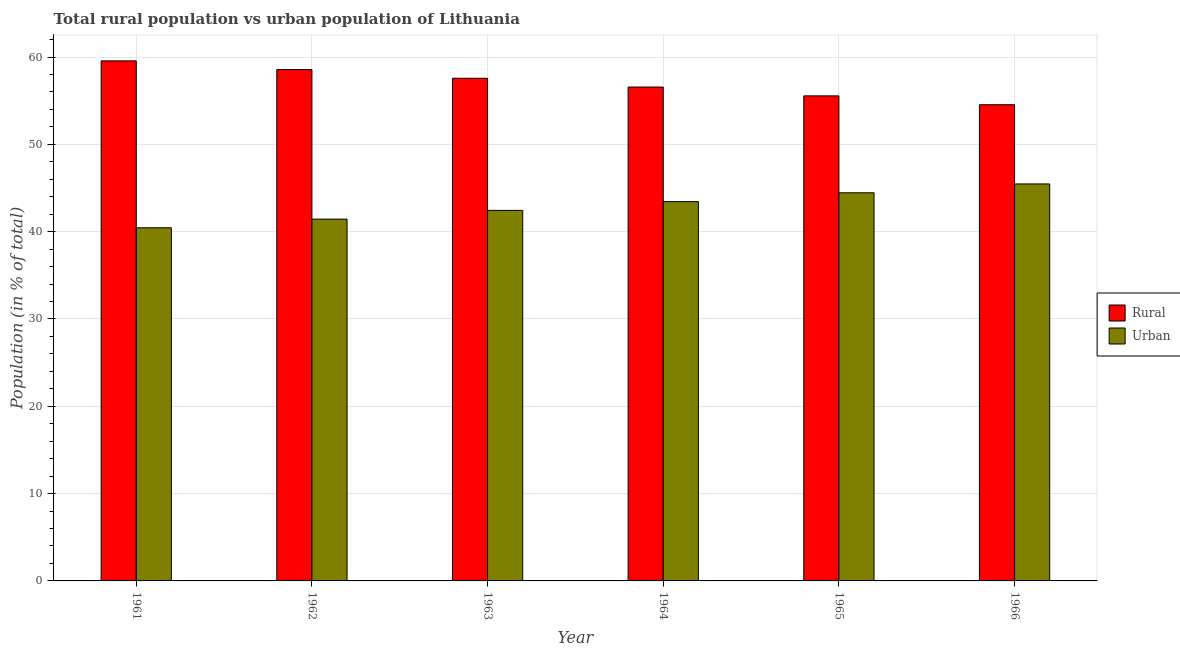How many different coloured bars are there?
Keep it short and to the point. 2. Are the number of bars per tick equal to the number of legend labels?
Your answer should be compact. Yes. What is the rural population in 1961?
Your response must be concise. 59.56. Across all years, what is the maximum rural population?
Your response must be concise. 59.56. Across all years, what is the minimum urban population?
Your answer should be compact. 40.44. In which year was the urban population maximum?
Ensure brevity in your answer.  1966. What is the total urban population in the graph?
Your answer should be very brief. 257.67. What is the difference between the rural population in 1962 and that in 1965?
Make the answer very short. 3.02. What is the difference between the rural population in 1965 and the urban population in 1966?
Make the answer very short. 1.02. What is the average urban population per year?
Ensure brevity in your answer.  42.94. In the year 1962, what is the difference between the urban population and rural population?
Offer a terse response. 0. What is the ratio of the urban population in 1962 to that in 1965?
Offer a terse response. 0.93. Is the rural population in 1964 less than that in 1966?
Your answer should be compact. No. Is the difference between the urban population in 1962 and 1965 greater than the difference between the rural population in 1962 and 1965?
Offer a very short reply. No. What is the difference between the highest and the second highest rural population?
Make the answer very short. 0.99. What is the difference between the highest and the lowest urban population?
Keep it short and to the point. 5.02. Is the sum of the rural population in 1965 and 1966 greater than the maximum urban population across all years?
Your response must be concise. Yes. What does the 1st bar from the left in 1965 represents?
Provide a short and direct response. Rural. What does the 1st bar from the right in 1966 represents?
Offer a terse response. Urban. Are all the bars in the graph horizontal?
Keep it short and to the point. No. How many years are there in the graph?
Ensure brevity in your answer.  6. What is the difference between two consecutive major ticks on the Y-axis?
Keep it short and to the point. 10. Are the values on the major ticks of Y-axis written in scientific E-notation?
Offer a terse response. No. Does the graph contain any zero values?
Keep it short and to the point. No. Does the graph contain grids?
Keep it short and to the point. Yes. How are the legend labels stacked?
Provide a short and direct response. Vertical. What is the title of the graph?
Your response must be concise. Total rural population vs urban population of Lithuania. Does "Infant" appear as one of the legend labels in the graph?
Give a very brief answer. No. What is the label or title of the X-axis?
Ensure brevity in your answer.  Year. What is the label or title of the Y-axis?
Give a very brief answer. Population (in % of total). What is the Population (in % of total) in Rural in 1961?
Offer a terse response. 59.56. What is the Population (in % of total) in Urban in 1961?
Offer a terse response. 40.44. What is the Population (in % of total) of Rural in 1962?
Give a very brief answer. 58.56. What is the Population (in % of total) of Urban in 1962?
Your answer should be very brief. 41.44. What is the Population (in % of total) in Rural in 1963?
Provide a short and direct response. 57.57. What is the Population (in % of total) of Urban in 1963?
Give a very brief answer. 42.43. What is the Population (in % of total) in Rural in 1964?
Provide a short and direct response. 56.56. What is the Population (in % of total) in Urban in 1964?
Keep it short and to the point. 43.44. What is the Population (in % of total) in Rural in 1965?
Your answer should be compact. 55.55. What is the Population (in % of total) of Urban in 1965?
Keep it short and to the point. 44.45. What is the Population (in % of total) in Rural in 1966?
Offer a very short reply. 54.53. What is the Population (in % of total) of Urban in 1966?
Provide a short and direct response. 45.47. Across all years, what is the maximum Population (in % of total) of Rural?
Make the answer very short. 59.56. Across all years, what is the maximum Population (in % of total) in Urban?
Offer a very short reply. 45.47. Across all years, what is the minimum Population (in % of total) in Rural?
Ensure brevity in your answer.  54.53. Across all years, what is the minimum Population (in % of total) of Urban?
Provide a short and direct response. 40.44. What is the total Population (in % of total) in Rural in the graph?
Provide a succinct answer. 342.33. What is the total Population (in % of total) of Urban in the graph?
Ensure brevity in your answer.  257.67. What is the difference between the Population (in % of total) in Urban in 1961 and that in 1962?
Your answer should be compact. -0.99. What is the difference between the Population (in % of total) of Rural in 1961 and that in 1963?
Provide a short and direct response. 1.99. What is the difference between the Population (in % of total) in Urban in 1961 and that in 1963?
Your answer should be compact. -1.99. What is the difference between the Population (in % of total) of Rural in 1961 and that in 1964?
Offer a very short reply. 3. What is the difference between the Population (in % of total) in Urban in 1961 and that in 1964?
Offer a very short reply. -3. What is the difference between the Population (in % of total) in Rural in 1961 and that in 1965?
Your answer should be very brief. 4.01. What is the difference between the Population (in % of total) of Urban in 1961 and that in 1965?
Offer a terse response. -4.01. What is the difference between the Population (in % of total) in Rural in 1961 and that in 1966?
Keep it short and to the point. 5.02. What is the difference between the Population (in % of total) of Urban in 1961 and that in 1966?
Offer a terse response. -5.02. What is the difference between the Population (in % of total) of Rural in 1962 and that in 1963?
Your answer should be very brief. 1. What is the difference between the Population (in % of total) in Urban in 1962 and that in 1963?
Keep it short and to the point. -1. What is the difference between the Population (in % of total) in Rural in 1962 and that in 1964?
Keep it short and to the point. 2.01. What is the difference between the Population (in % of total) of Urban in 1962 and that in 1964?
Your answer should be compact. -2.01. What is the difference between the Population (in % of total) of Rural in 1962 and that in 1965?
Your answer should be compact. 3.02. What is the difference between the Population (in % of total) in Urban in 1962 and that in 1965?
Your answer should be compact. -3.02. What is the difference between the Population (in % of total) of Rural in 1962 and that in 1966?
Your answer should be very brief. 4.03. What is the difference between the Population (in % of total) in Urban in 1962 and that in 1966?
Provide a succinct answer. -4.03. What is the difference between the Population (in % of total) in Rural in 1963 and that in 1964?
Your answer should be compact. 1.01. What is the difference between the Population (in % of total) of Urban in 1963 and that in 1964?
Ensure brevity in your answer.  -1.01. What is the difference between the Population (in % of total) of Rural in 1963 and that in 1965?
Offer a terse response. 2.02. What is the difference between the Population (in % of total) of Urban in 1963 and that in 1965?
Keep it short and to the point. -2.02. What is the difference between the Population (in % of total) in Rural in 1963 and that in 1966?
Ensure brevity in your answer.  3.03. What is the difference between the Population (in % of total) in Urban in 1963 and that in 1966?
Give a very brief answer. -3.03. What is the difference between the Population (in % of total) of Rural in 1964 and that in 1965?
Your answer should be compact. 1.01. What is the difference between the Population (in % of total) in Urban in 1964 and that in 1965?
Provide a succinct answer. -1.01. What is the difference between the Population (in % of total) of Rural in 1964 and that in 1966?
Provide a short and direct response. 2.02. What is the difference between the Population (in % of total) in Urban in 1964 and that in 1966?
Keep it short and to the point. -2.02. What is the difference between the Population (in % of total) in Urban in 1965 and that in 1966?
Provide a succinct answer. -1.01. What is the difference between the Population (in % of total) in Rural in 1961 and the Population (in % of total) in Urban in 1962?
Keep it short and to the point. 18.12. What is the difference between the Population (in % of total) of Rural in 1961 and the Population (in % of total) of Urban in 1963?
Your answer should be compact. 17.12. What is the difference between the Population (in % of total) in Rural in 1961 and the Population (in % of total) in Urban in 1964?
Offer a very short reply. 16.12. What is the difference between the Population (in % of total) in Rural in 1961 and the Population (in % of total) in Urban in 1965?
Your answer should be very brief. 15.11. What is the difference between the Population (in % of total) in Rural in 1961 and the Population (in % of total) in Urban in 1966?
Provide a succinct answer. 14.09. What is the difference between the Population (in % of total) of Rural in 1962 and the Population (in % of total) of Urban in 1963?
Your answer should be very brief. 16.13. What is the difference between the Population (in % of total) of Rural in 1962 and the Population (in % of total) of Urban in 1964?
Your answer should be compact. 15.12. What is the difference between the Population (in % of total) of Rural in 1962 and the Population (in % of total) of Urban in 1965?
Offer a very short reply. 14.12. What is the difference between the Population (in % of total) of Rural in 1963 and the Population (in % of total) of Urban in 1964?
Give a very brief answer. 14.12. What is the difference between the Population (in % of total) of Rural in 1963 and the Population (in % of total) of Urban in 1965?
Provide a short and direct response. 13.12. What is the difference between the Population (in % of total) of Rural in 1963 and the Population (in % of total) of Urban in 1966?
Make the answer very short. 12.1. What is the difference between the Population (in % of total) in Rural in 1964 and the Population (in % of total) in Urban in 1965?
Provide a succinct answer. 12.11. What is the difference between the Population (in % of total) of Rural in 1964 and the Population (in % of total) of Urban in 1966?
Keep it short and to the point. 11.09. What is the difference between the Population (in % of total) of Rural in 1965 and the Population (in % of total) of Urban in 1966?
Provide a short and direct response. 10.09. What is the average Population (in % of total) of Rural per year?
Provide a short and direct response. 57.06. What is the average Population (in % of total) of Urban per year?
Keep it short and to the point. 42.94. In the year 1961, what is the difference between the Population (in % of total) of Rural and Population (in % of total) of Urban?
Your response must be concise. 19.11. In the year 1962, what is the difference between the Population (in % of total) of Rural and Population (in % of total) of Urban?
Provide a short and direct response. 17.13. In the year 1963, what is the difference between the Population (in % of total) in Rural and Population (in % of total) in Urban?
Provide a short and direct response. 15.13. In the year 1964, what is the difference between the Population (in % of total) of Rural and Population (in % of total) of Urban?
Offer a terse response. 13.12. In the year 1966, what is the difference between the Population (in % of total) in Rural and Population (in % of total) in Urban?
Your response must be concise. 9.07. What is the ratio of the Population (in % of total) in Rural in 1961 to that in 1962?
Offer a terse response. 1.02. What is the ratio of the Population (in % of total) of Urban in 1961 to that in 1962?
Provide a succinct answer. 0.98. What is the ratio of the Population (in % of total) in Rural in 1961 to that in 1963?
Make the answer very short. 1.03. What is the ratio of the Population (in % of total) in Urban in 1961 to that in 1963?
Your answer should be very brief. 0.95. What is the ratio of the Population (in % of total) in Rural in 1961 to that in 1964?
Ensure brevity in your answer.  1.05. What is the ratio of the Population (in % of total) in Urban in 1961 to that in 1964?
Provide a short and direct response. 0.93. What is the ratio of the Population (in % of total) of Rural in 1961 to that in 1965?
Offer a terse response. 1.07. What is the ratio of the Population (in % of total) in Urban in 1961 to that in 1965?
Your answer should be very brief. 0.91. What is the ratio of the Population (in % of total) in Rural in 1961 to that in 1966?
Offer a very short reply. 1.09. What is the ratio of the Population (in % of total) in Urban in 1961 to that in 1966?
Offer a terse response. 0.89. What is the ratio of the Population (in % of total) of Rural in 1962 to that in 1963?
Your answer should be compact. 1.02. What is the ratio of the Population (in % of total) of Urban in 1962 to that in 1963?
Give a very brief answer. 0.98. What is the ratio of the Population (in % of total) in Rural in 1962 to that in 1964?
Provide a short and direct response. 1.04. What is the ratio of the Population (in % of total) in Urban in 1962 to that in 1964?
Offer a very short reply. 0.95. What is the ratio of the Population (in % of total) in Rural in 1962 to that in 1965?
Provide a short and direct response. 1.05. What is the ratio of the Population (in % of total) in Urban in 1962 to that in 1965?
Offer a very short reply. 0.93. What is the ratio of the Population (in % of total) in Rural in 1962 to that in 1966?
Ensure brevity in your answer.  1.07. What is the ratio of the Population (in % of total) in Urban in 1962 to that in 1966?
Offer a very short reply. 0.91. What is the ratio of the Population (in % of total) in Rural in 1963 to that in 1964?
Offer a very short reply. 1.02. What is the ratio of the Population (in % of total) in Urban in 1963 to that in 1964?
Give a very brief answer. 0.98. What is the ratio of the Population (in % of total) of Rural in 1963 to that in 1965?
Provide a short and direct response. 1.04. What is the ratio of the Population (in % of total) of Urban in 1963 to that in 1965?
Offer a terse response. 0.95. What is the ratio of the Population (in % of total) of Rural in 1963 to that in 1966?
Offer a very short reply. 1.06. What is the ratio of the Population (in % of total) in Rural in 1964 to that in 1965?
Provide a succinct answer. 1.02. What is the ratio of the Population (in % of total) in Urban in 1964 to that in 1965?
Give a very brief answer. 0.98. What is the ratio of the Population (in % of total) of Rural in 1964 to that in 1966?
Your answer should be very brief. 1.04. What is the ratio of the Population (in % of total) of Urban in 1964 to that in 1966?
Your response must be concise. 0.96. What is the ratio of the Population (in % of total) of Rural in 1965 to that in 1966?
Make the answer very short. 1.02. What is the ratio of the Population (in % of total) of Urban in 1965 to that in 1966?
Offer a very short reply. 0.98. What is the difference between the highest and the second highest Population (in % of total) in Rural?
Make the answer very short. 0.99. What is the difference between the highest and the second highest Population (in % of total) in Urban?
Your answer should be very brief. 1.01. What is the difference between the highest and the lowest Population (in % of total) in Rural?
Offer a terse response. 5.02. What is the difference between the highest and the lowest Population (in % of total) of Urban?
Offer a very short reply. 5.02. 